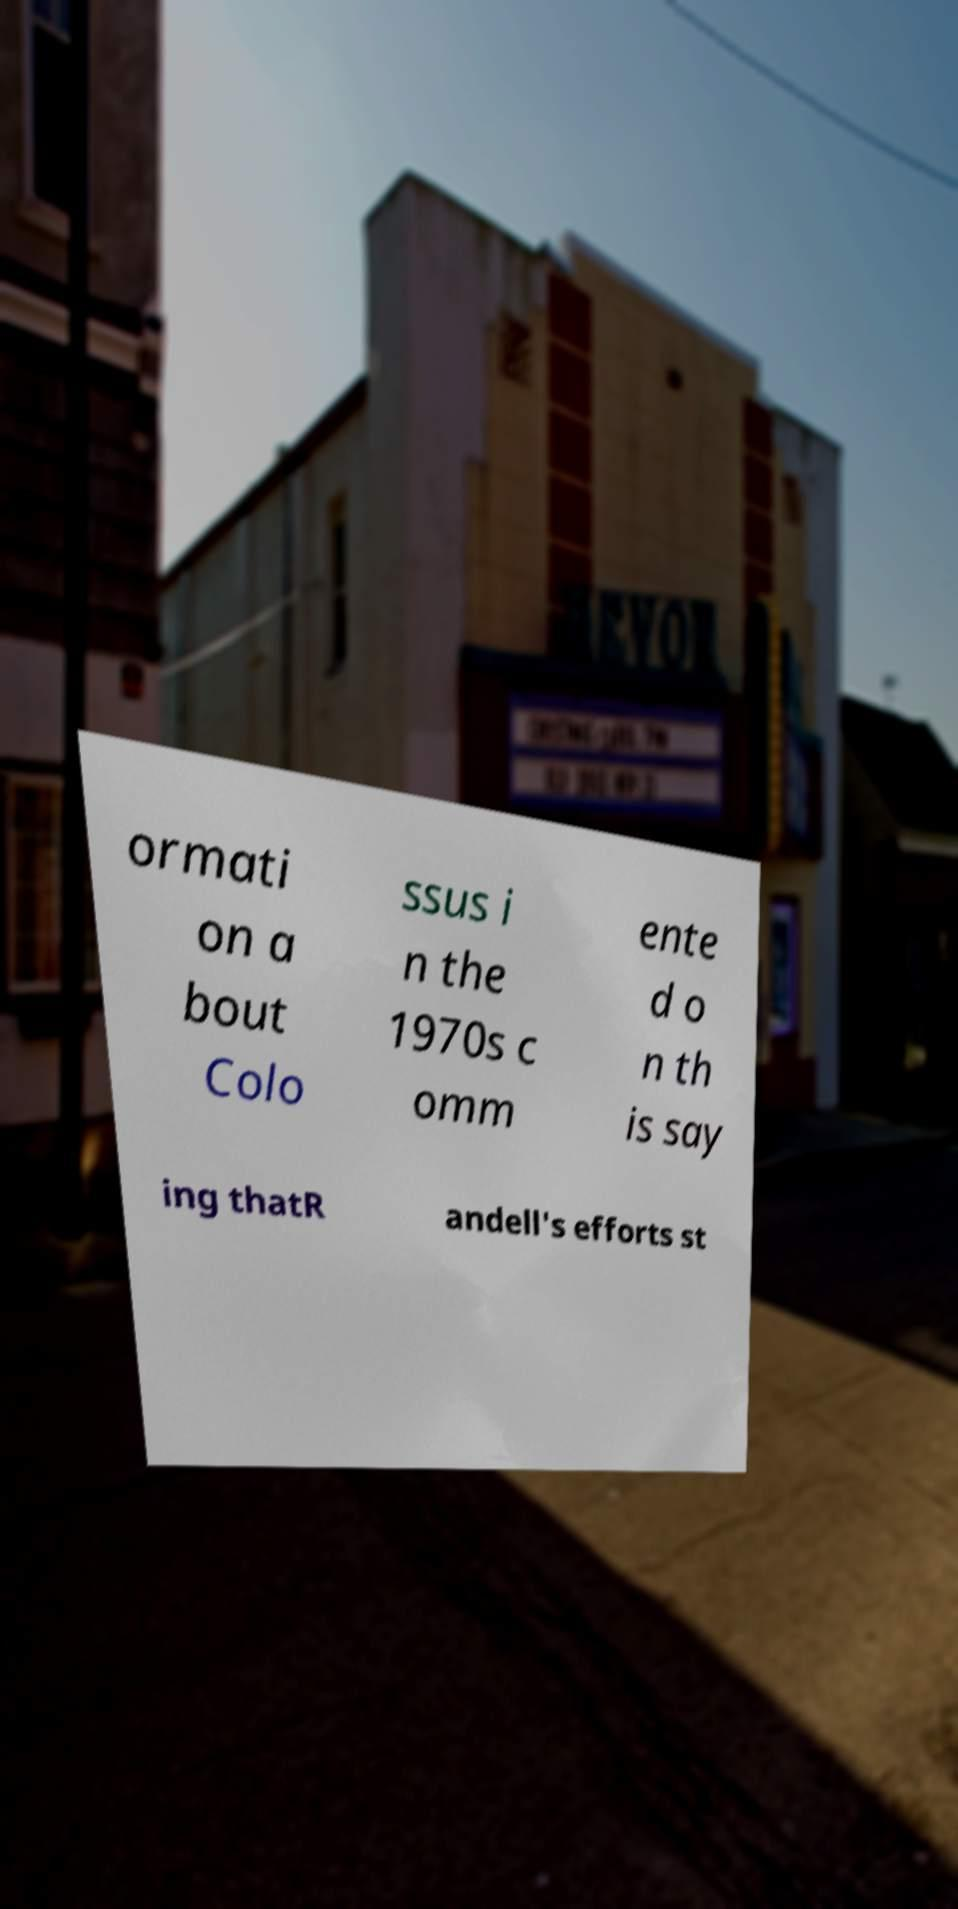Can you accurately transcribe the text from the provided image for me? ormati on a bout Colo ssus i n the 1970s c omm ente d o n th is say ing thatR andell's efforts st 